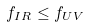Convert formula to latex. <formula><loc_0><loc_0><loc_500><loc_500>f _ { I R } \leq f _ { U V } \</formula> 